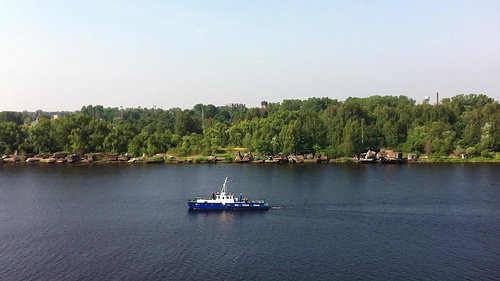Please provide the bounding box coordinate of the region this sentence describes: you can see the wake behind the boat. The turbulent wake formed by the boat can be distinctly observed in the region stretching from [0.54, 0.62, 1.0, 0.65], highlighting the boat's recent path through the water. 